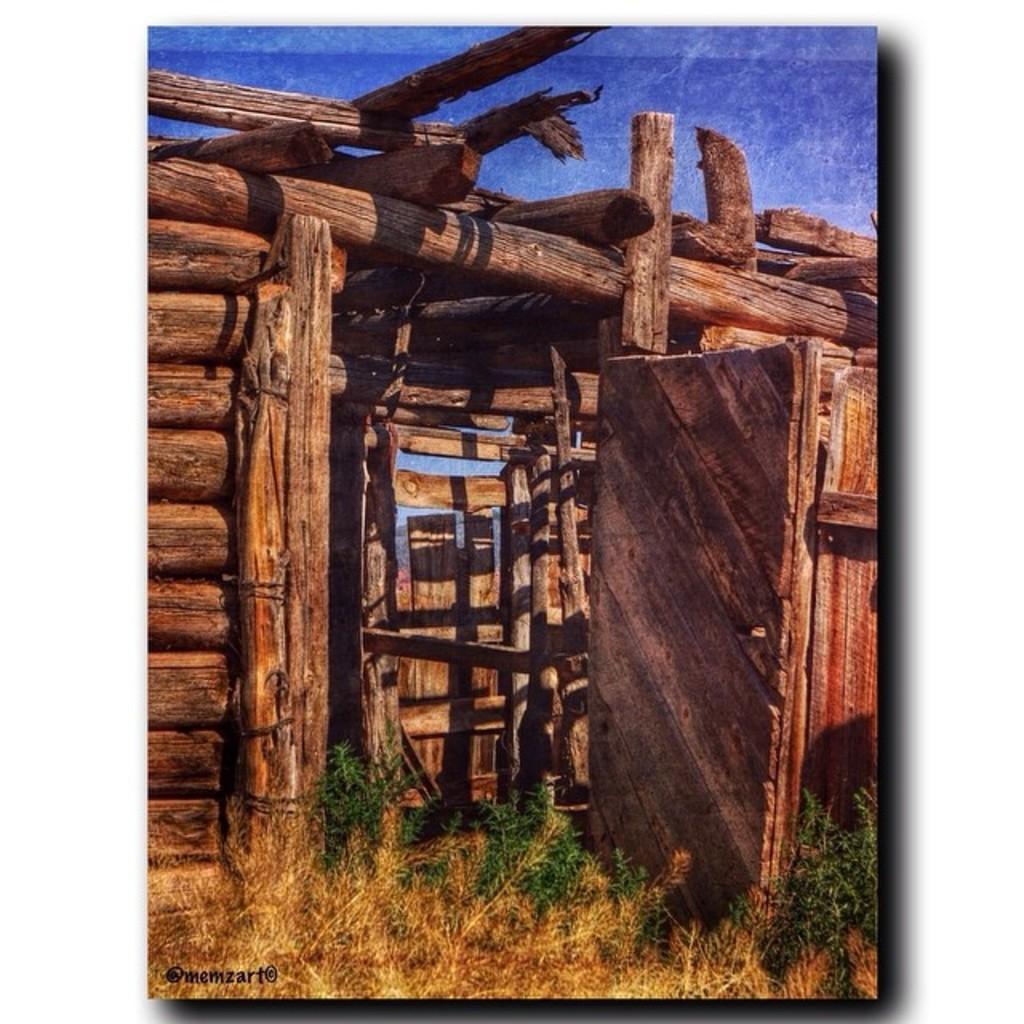Please provide a concise description of this image. This image consists of a cabin which is made up of wood. It looks like a frame. 